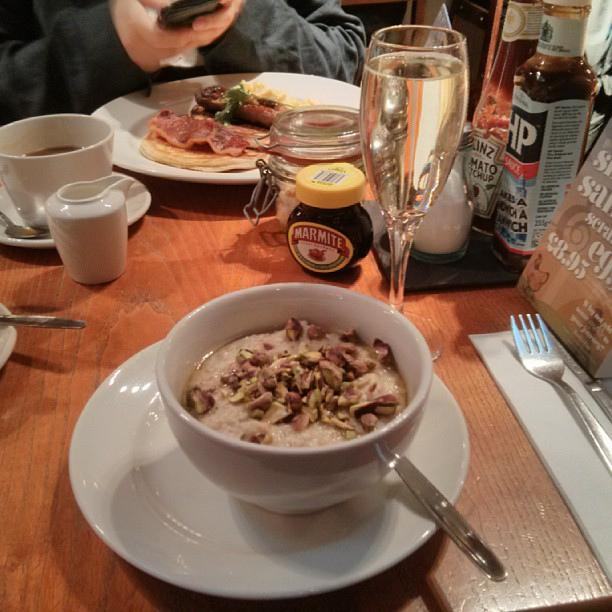The person that invented the item with the yellow lid was from what country? Please explain your reasoning. germany. The product was discovered as an edible item by a scientist from this country. 